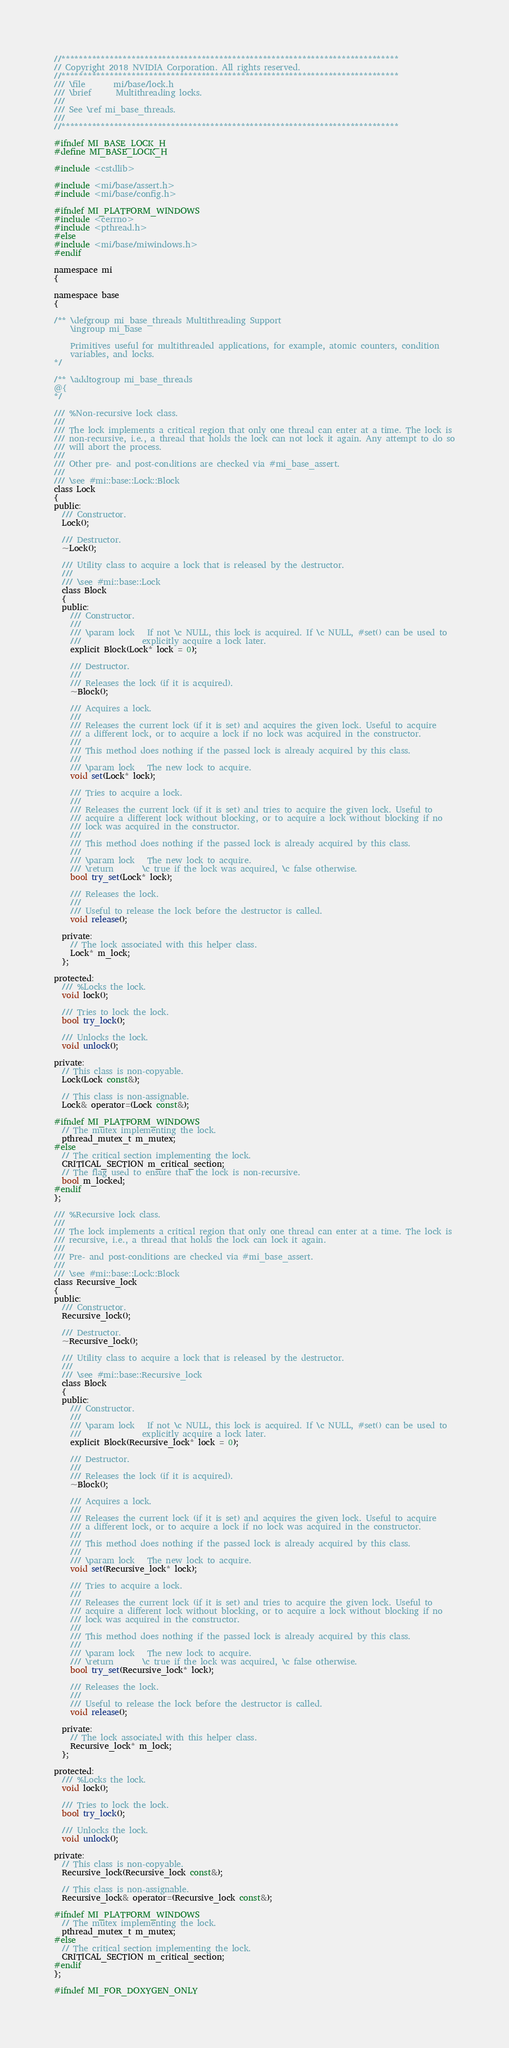<code> <loc_0><loc_0><loc_500><loc_500><_C_>//*****************************************************************************
// Copyright 2018 NVIDIA Corporation. All rights reserved.
//*****************************************************************************
/// \file       mi/base/lock.h
/// \brief      Multithreading locks.
///
/// See \ref mi_base_threads.
///
//*****************************************************************************

#ifndef MI_BASE_LOCK_H
#define MI_BASE_LOCK_H

#include <cstdlib>

#include <mi/base/assert.h>
#include <mi/base/config.h>

#ifndef MI_PLATFORM_WINDOWS
#include <cerrno>
#include <pthread.h>
#else
#include <mi/base/miwindows.h>
#endif

namespace mi
{

namespace base
{

/** \defgroup mi_base_threads Multithreading Support
    \ingroup mi_base

    Primitives useful for multithreaded applications, for example, atomic counters, condition
    variables, and locks.
*/

/** \addtogroup mi_base_threads
@{
*/

/// %Non-recursive lock class.
///
/// The lock implements a critical region that only one thread can enter at a time. The lock is
/// non-recursive, i.e., a thread that holds the lock can not lock it again. Any attempt to do so
/// will abort the process.
///
/// Other pre- and post-conditions are checked via #mi_base_assert.
///
/// \see #mi::base::Lock::Block
class Lock
{
public:
  /// Constructor.
  Lock();

  /// Destructor.
  ~Lock();

  /// Utility class to acquire a lock that is released by the destructor.
  ///
  /// \see #mi::base::Lock
  class Block
  {
  public:
    /// Constructor.
    ///
    /// \param lock   If not \c NULL, this lock is acquired. If \c NULL, #set() can be used to
    ///               explicitly acquire a lock later.
    explicit Block(Lock* lock = 0);

    /// Destructor.
    ///
    /// Releases the lock (if it is acquired).
    ~Block();

    /// Acquires a lock.
    ///
    /// Releases the current lock (if it is set) and acquires the given lock. Useful to acquire
    /// a different lock, or to acquire a lock if no lock was acquired in the constructor.
    ///
    /// This method does nothing if the passed lock is already acquired by this class.
    ///
    /// \param lock   The new lock to acquire.
    void set(Lock* lock);

    /// Tries to acquire a lock.
    ///
    /// Releases the current lock (if it is set) and tries to acquire the given lock. Useful to
    /// acquire a different lock without blocking, or to acquire a lock without blocking if no
    /// lock was acquired in the constructor.
    ///
    /// This method does nothing if the passed lock is already acquired by this class.
    ///
    /// \param lock   The new lock to acquire.
    /// \return       \c true if the lock was acquired, \c false otherwise.
    bool try_set(Lock* lock);

    /// Releases the lock.
    ///
    /// Useful to release the lock before the destructor is called.
    void release();

  private:
    // The lock associated with this helper class.
    Lock* m_lock;
  };

protected:
  /// %Locks the lock.
  void lock();

  /// Tries to lock the lock.
  bool try_lock();

  /// Unlocks the lock.
  void unlock();

private:
  // This class is non-copyable.
  Lock(Lock const&);

  // This class is non-assignable.
  Lock& operator=(Lock const&);

#ifndef MI_PLATFORM_WINDOWS
  // The mutex implementing the lock.
  pthread_mutex_t m_mutex;
#else
  // The critical section implementing the lock.
  CRITICAL_SECTION m_critical_section;
  // The flag used to ensure that the lock is non-recursive.
  bool m_locked;
#endif
};

/// %Recursive lock class.
///
/// The lock implements a critical region that only one thread can enter at a time. The lock is
/// recursive, i.e., a thread that holds the lock can lock it again.
///
/// Pre- and post-conditions are checked via #mi_base_assert.
///
/// \see #mi::base::Lock::Block
class Recursive_lock
{
public:
  /// Constructor.
  Recursive_lock();

  /// Destructor.
  ~Recursive_lock();

  /// Utility class to acquire a lock that is released by the destructor.
  ///
  /// \see #mi::base::Recursive_lock
  class Block
  {
  public:
    /// Constructor.
    ///
    /// \param lock   If not \c NULL, this lock is acquired. If \c NULL, #set() can be used to
    ///               explicitly acquire a lock later.
    explicit Block(Recursive_lock* lock = 0);

    /// Destructor.
    ///
    /// Releases the lock (if it is acquired).
    ~Block();

    /// Acquires a lock.
    ///
    /// Releases the current lock (if it is set) and acquires the given lock. Useful to acquire
    /// a different lock, or to acquire a lock if no lock was acquired in the constructor.
    ///
    /// This method does nothing if the passed lock is already acquired by this class.
    ///
    /// \param lock   The new lock to acquire.
    void set(Recursive_lock* lock);

    /// Tries to acquire a lock.
    ///
    /// Releases the current lock (if it is set) and tries to acquire the given lock. Useful to
    /// acquire a different lock without blocking, or to acquire a lock without blocking if no
    /// lock was acquired in the constructor.
    ///
    /// This method does nothing if the passed lock is already acquired by this class.
    ///
    /// \param lock   The new lock to acquire.
    /// \return       \c true if the lock was acquired, \c false otherwise.
    bool try_set(Recursive_lock* lock);

    /// Releases the lock.
    ///
    /// Useful to release the lock before the destructor is called.
    void release();

  private:
    // The lock associated with this helper class.
    Recursive_lock* m_lock;
  };

protected:
  /// %Locks the lock.
  void lock();

  /// Tries to lock the lock.
  bool try_lock();

  /// Unlocks the lock.
  void unlock();

private:
  // This class is non-copyable.
  Recursive_lock(Recursive_lock const&);

  // This class is non-assignable.
  Recursive_lock& operator=(Recursive_lock const&);

#ifndef MI_PLATFORM_WINDOWS
  // The mutex implementing the lock.
  pthread_mutex_t m_mutex;
#else
  // The critical section implementing the lock.
  CRITICAL_SECTION m_critical_section;
#endif
};

#ifndef MI_FOR_DOXYGEN_ONLY
</code> 